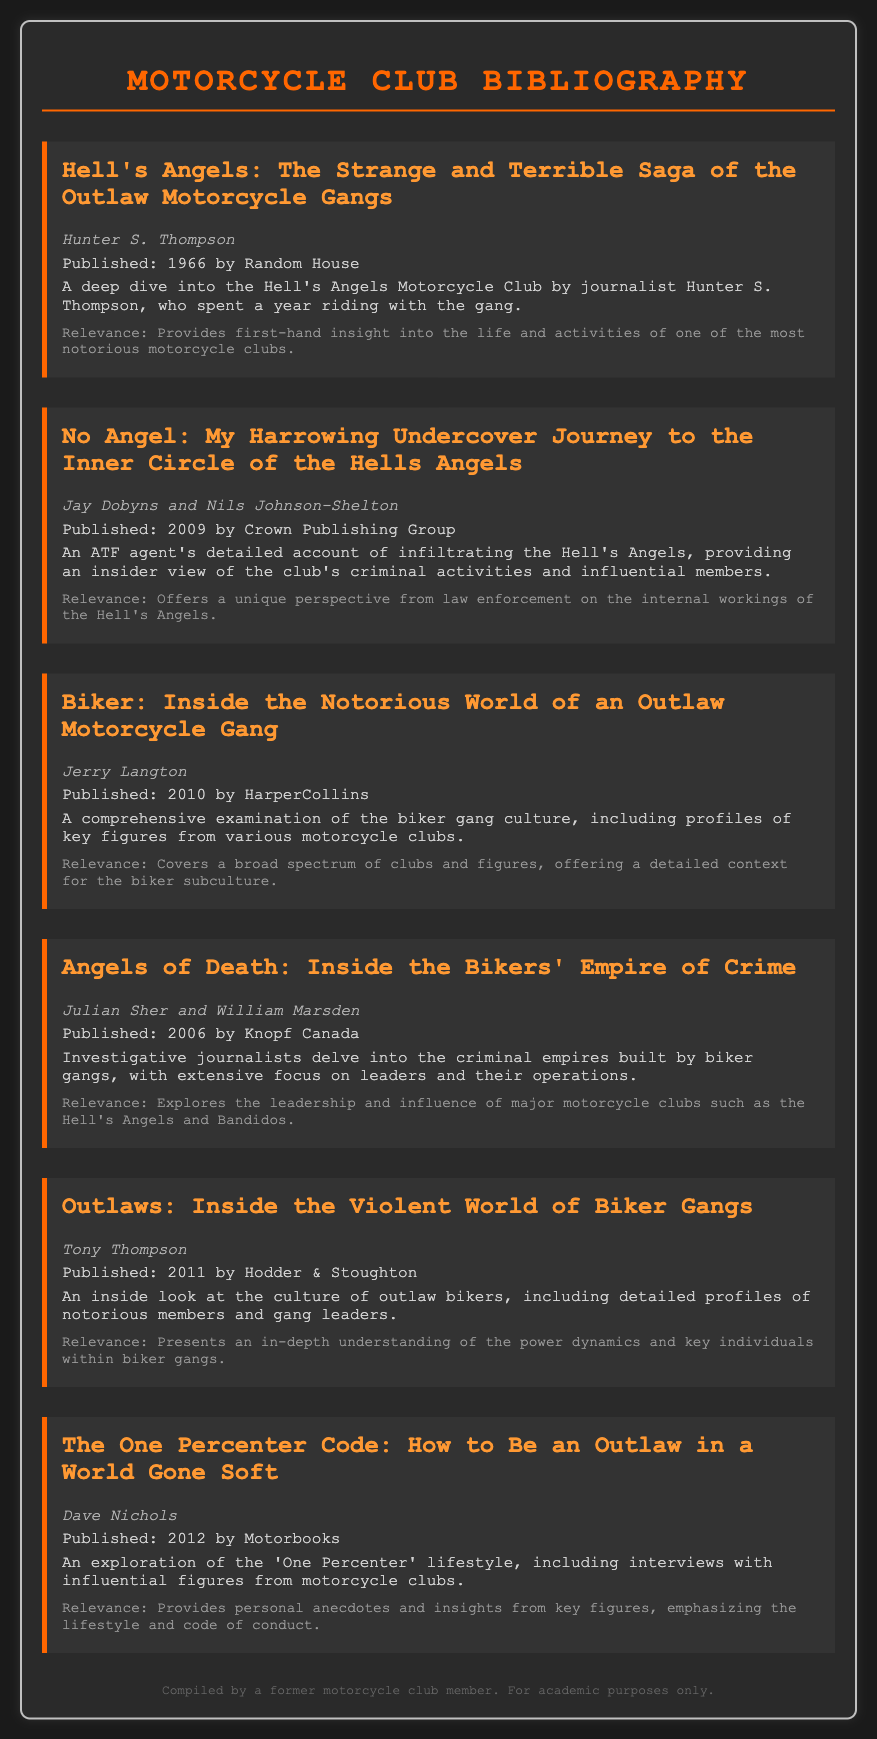What is the title of the first book listed? The first book listed in the document is titled "Hell's Angels: The Strange and Terrible Saga of the Outlaw Motorcycle Gangs."
Answer: Hell's Angels: The Strange and Terrible Saga of the Outlaw Motorcycle Gangs Who is the author of "No Angel"? The book "No Angel" is co-authored by Jay Dobyns and Nils Johnson-Shelton.
Answer: Jay Dobyns and Nils Johnson-Shelton In what year was "Biker" published? The book "Biker" was published in the year 2010.
Answer: 2010 What type of account does "Angels of Death" offer? "Angels of Death" provides an investigative journalism account focusing on biker gangs and their criminal empires.
Answer: Investigative account Which book discusses the 'One Percenter' lifestyle? The book that discusses the 'One Percenter' lifestyle is "The One Percenter Code: How to Be an Outlaw in a World Gone Soft."
Answer: The One Percenter Code: How to Be an Outlaw in a World Gone Soft What specific focus does "Outlaws" provide? "Outlaws" provides a detailed focus on the culture of outlaw bikers, including profiles of notorious members and gang leaders.
Answer: Culture of outlaw bikers What publishing company released "Hell's Angels"? "Hell's Angels" was published by Random House.
Answer: Random House What is the common theme of all the books listed? The common theme of all the books listed is the examination of motorcycle clubs and their influential figures throughout history.
Answer: Examination of motorcycle clubs and influential figures 